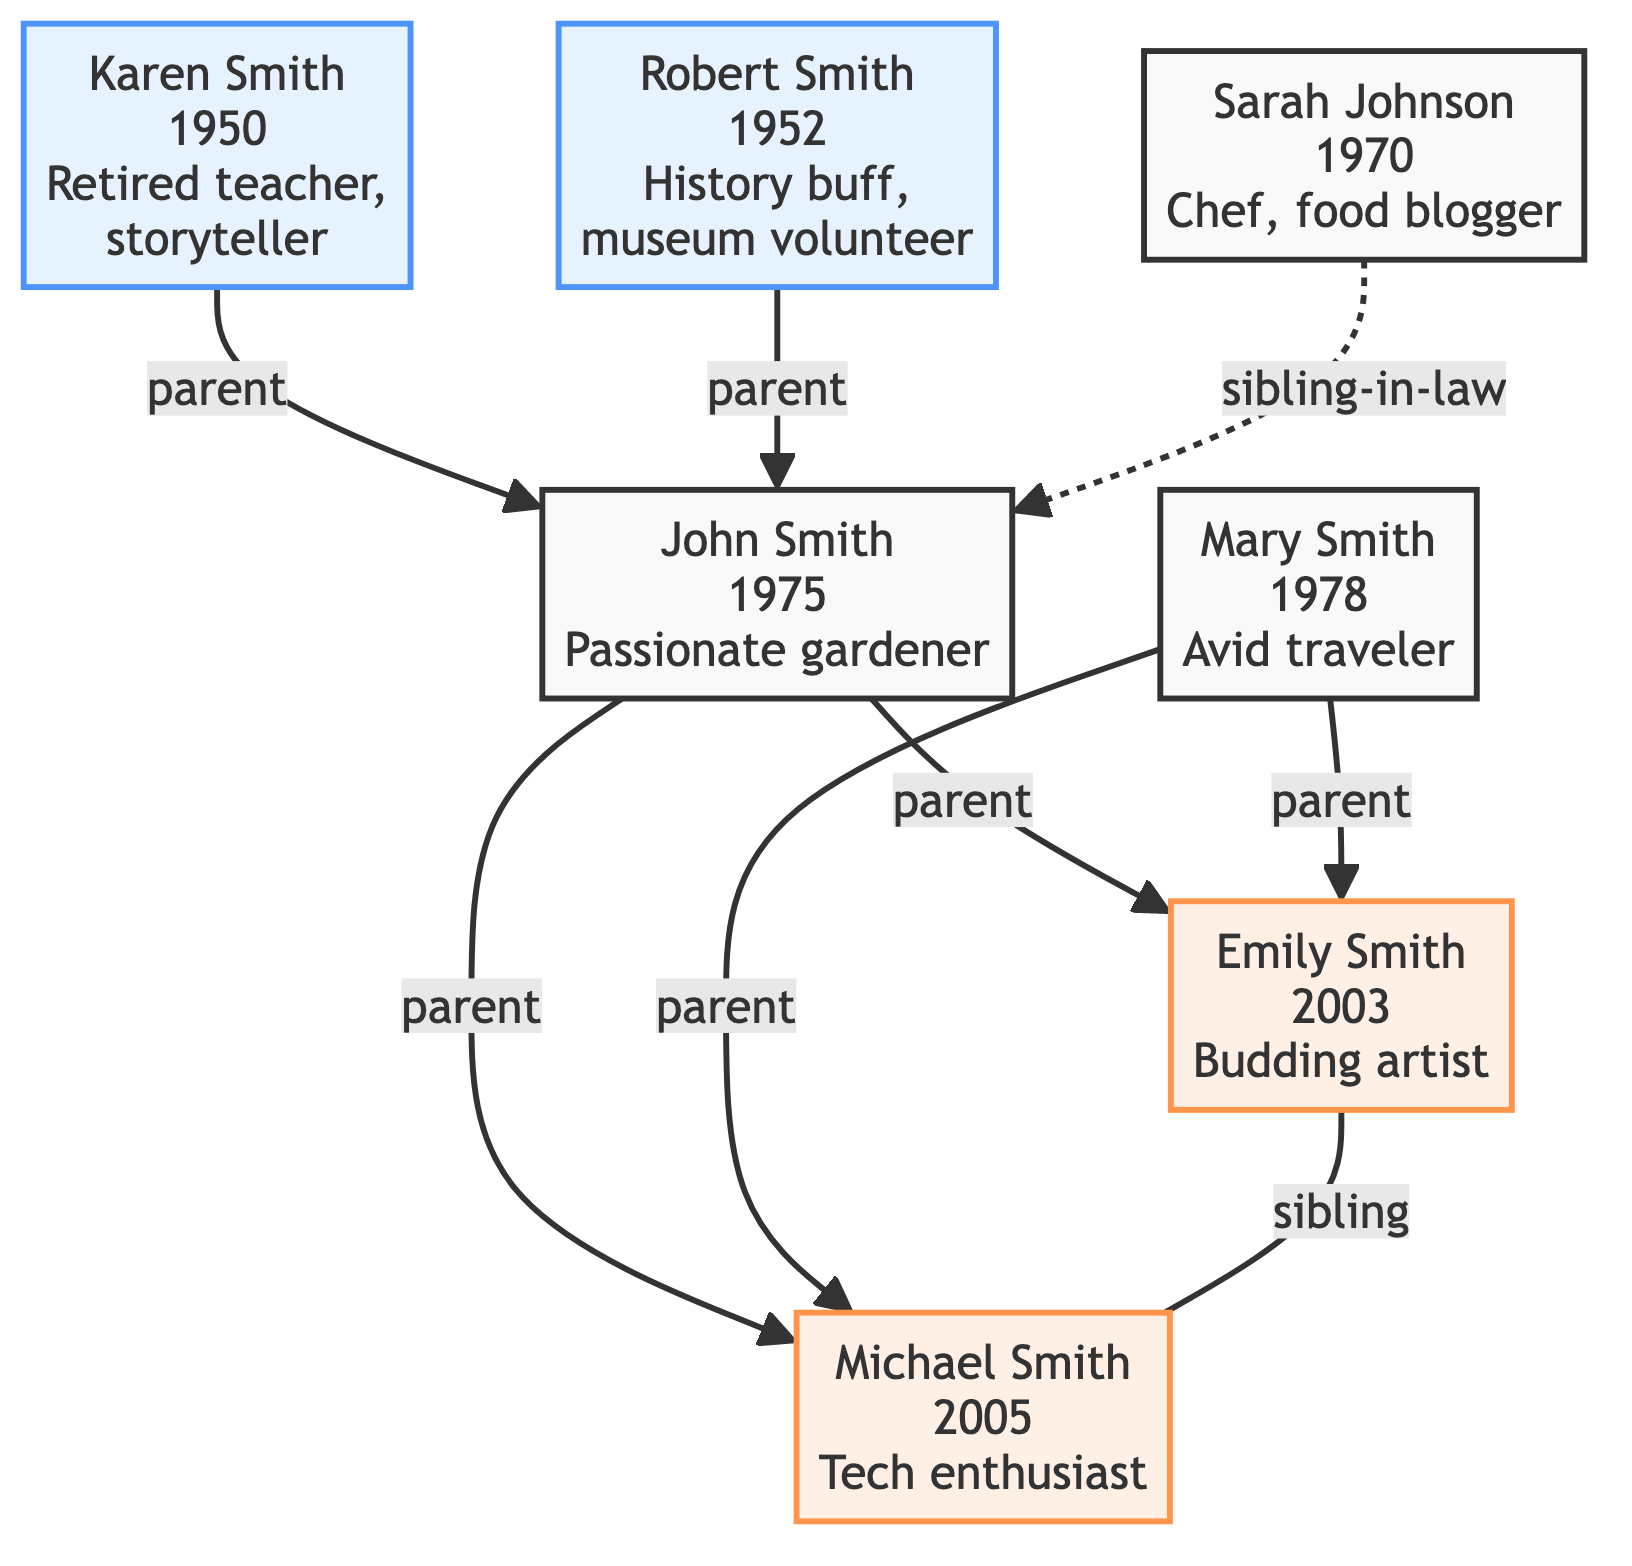What is the birth year of John Smith? John Smith is represented by node 1 in the diagram. Upon inspecting this node, it indicates that his birth year is 1975.
Answer: 1975 Who are the parents of Emily Smith? Emily Smith is identified as node 3 in the diagram. The arrows leading into this node from nodes 1 and 2 indicate that John Smith and Mary Smith are her parents.
Answer: John Smith, Mary Smith What is Michael Smith's unique story? Michael Smith is represented by node 4 in the diagram. The description provided within this node states that he is a tech enthusiast who built his first app at age 10.
Answer: A tech enthusiast who built his first app at age 10 How many children does John Smith have? John Smith, represented by node 1, is connected by arrows to two child nodes: Emily Smith (node 3) and Michael Smith (node 4). Therefore, he has two children.
Answer: 2 What type of relationship exists between Emily Smith and Michael Smith? Emily Smith and Michael Smith are both children of John and Mary Smith; the line connecting nodes 3 and 4 indicates they have a sibling relationship.
Answer: Sibling How many parents are listed in the graph? The diagram shows two parents for John Smith (nodes 5 and 6) and two parents for Emily Smith and Michael Smith (nodes 1 and 2). Counting the unique parent nodes gives us a total of four parents.
Answer: 4 What is the relationship between Sarah Johnson and John Smith? The diagram shows an arrow from Sarah Johnson (node 7) to John Smith (node 1) marked as sibling-in-law. This indicates that Sarah Johnson is John Smith's sibling-in-law.
Answer: Sibling-in-law Which node has the unique story about gardening? Node 1 represents John Smith, whose unique story is about being a passionate gardener who started a community garden, as stated in his description.
Answer: John Smith What is the total number of nodes in the diagram? Counting each unique individual/relationship in the diagram, we find there are seven distinct nodes: John Smith, Mary Smith, Emily Smith, Michael Smith, Karen Smith, Robert Smith, and Sarah Johnson.
Answer: 7 